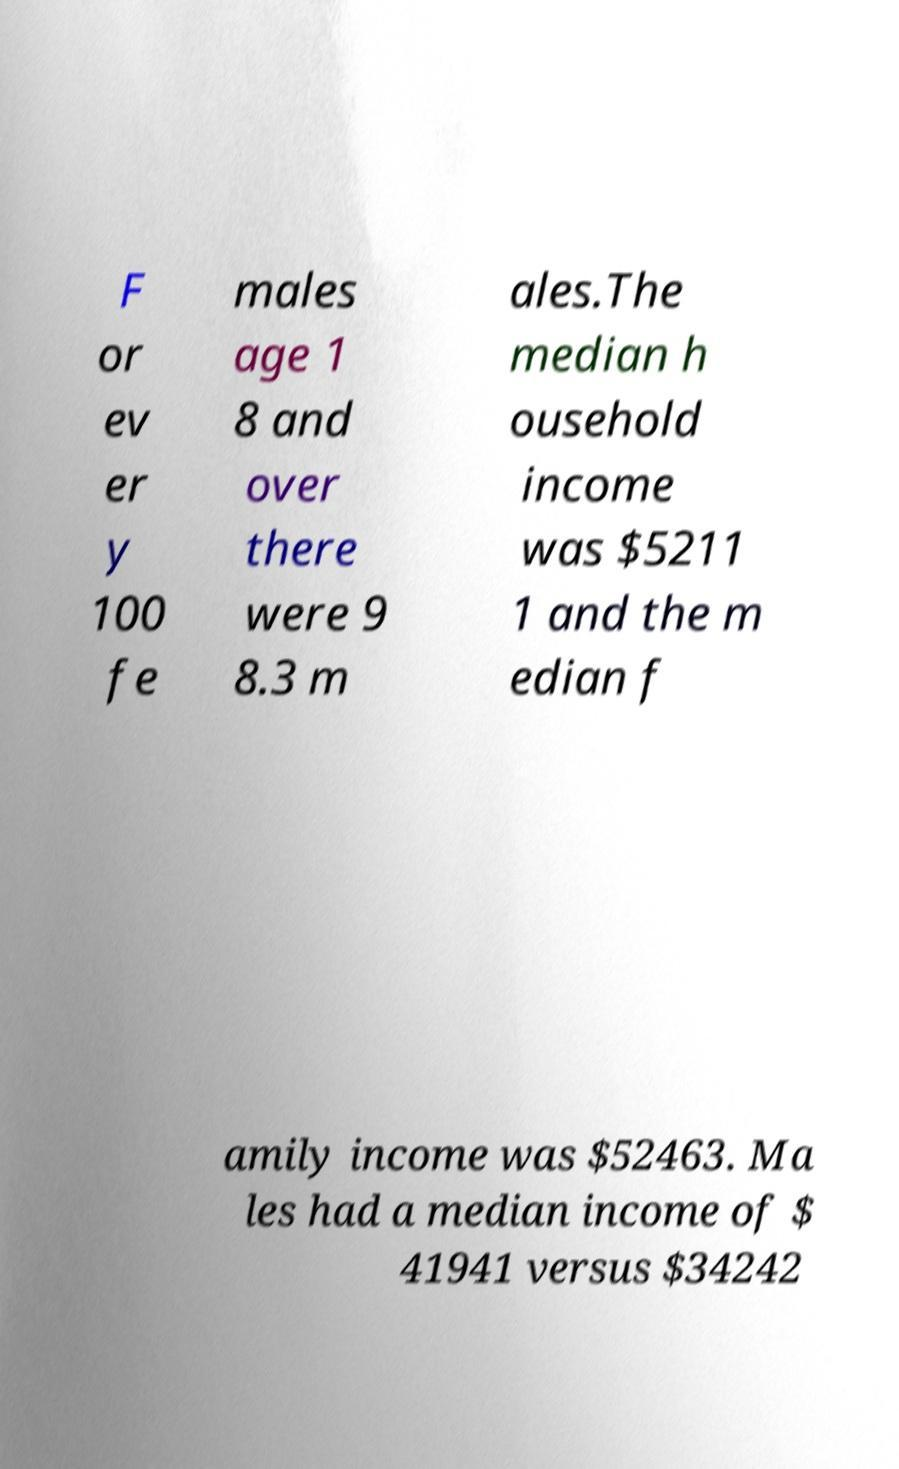Could you extract and type out the text from this image? F or ev er y 100 fe males age 1 8 and over there were 9 8.3 m ales.The median h ousehold income was $5211 1 and the m edian f amily income was $52463. Ma les had a median income of $ 41941 versus $34242 